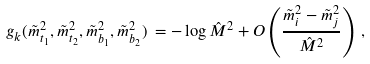<formula> <loc_0><loc_0><loc_500><loc_500>g _ { k } ( \tilde { m } _ { t _ { 1 } } ^ { 2 } , \tilde { m } _ { t _ { 2 } } ^ { 2 } , \tilde { m } _ { b _ { 1 } } ^ { 2 } , \tilde { m } _ { b _ { 2 } } ^ { 2 } ) \, = - \log \hat { M } ^ { 2 } + O \left ( \frac { \tilde { m } _ { i } ^ { 2 } - \tilde { m } _ { j } ^ { 2 } } { \hat { M } ^ { 2 } } \right ) \, ,</formula> 